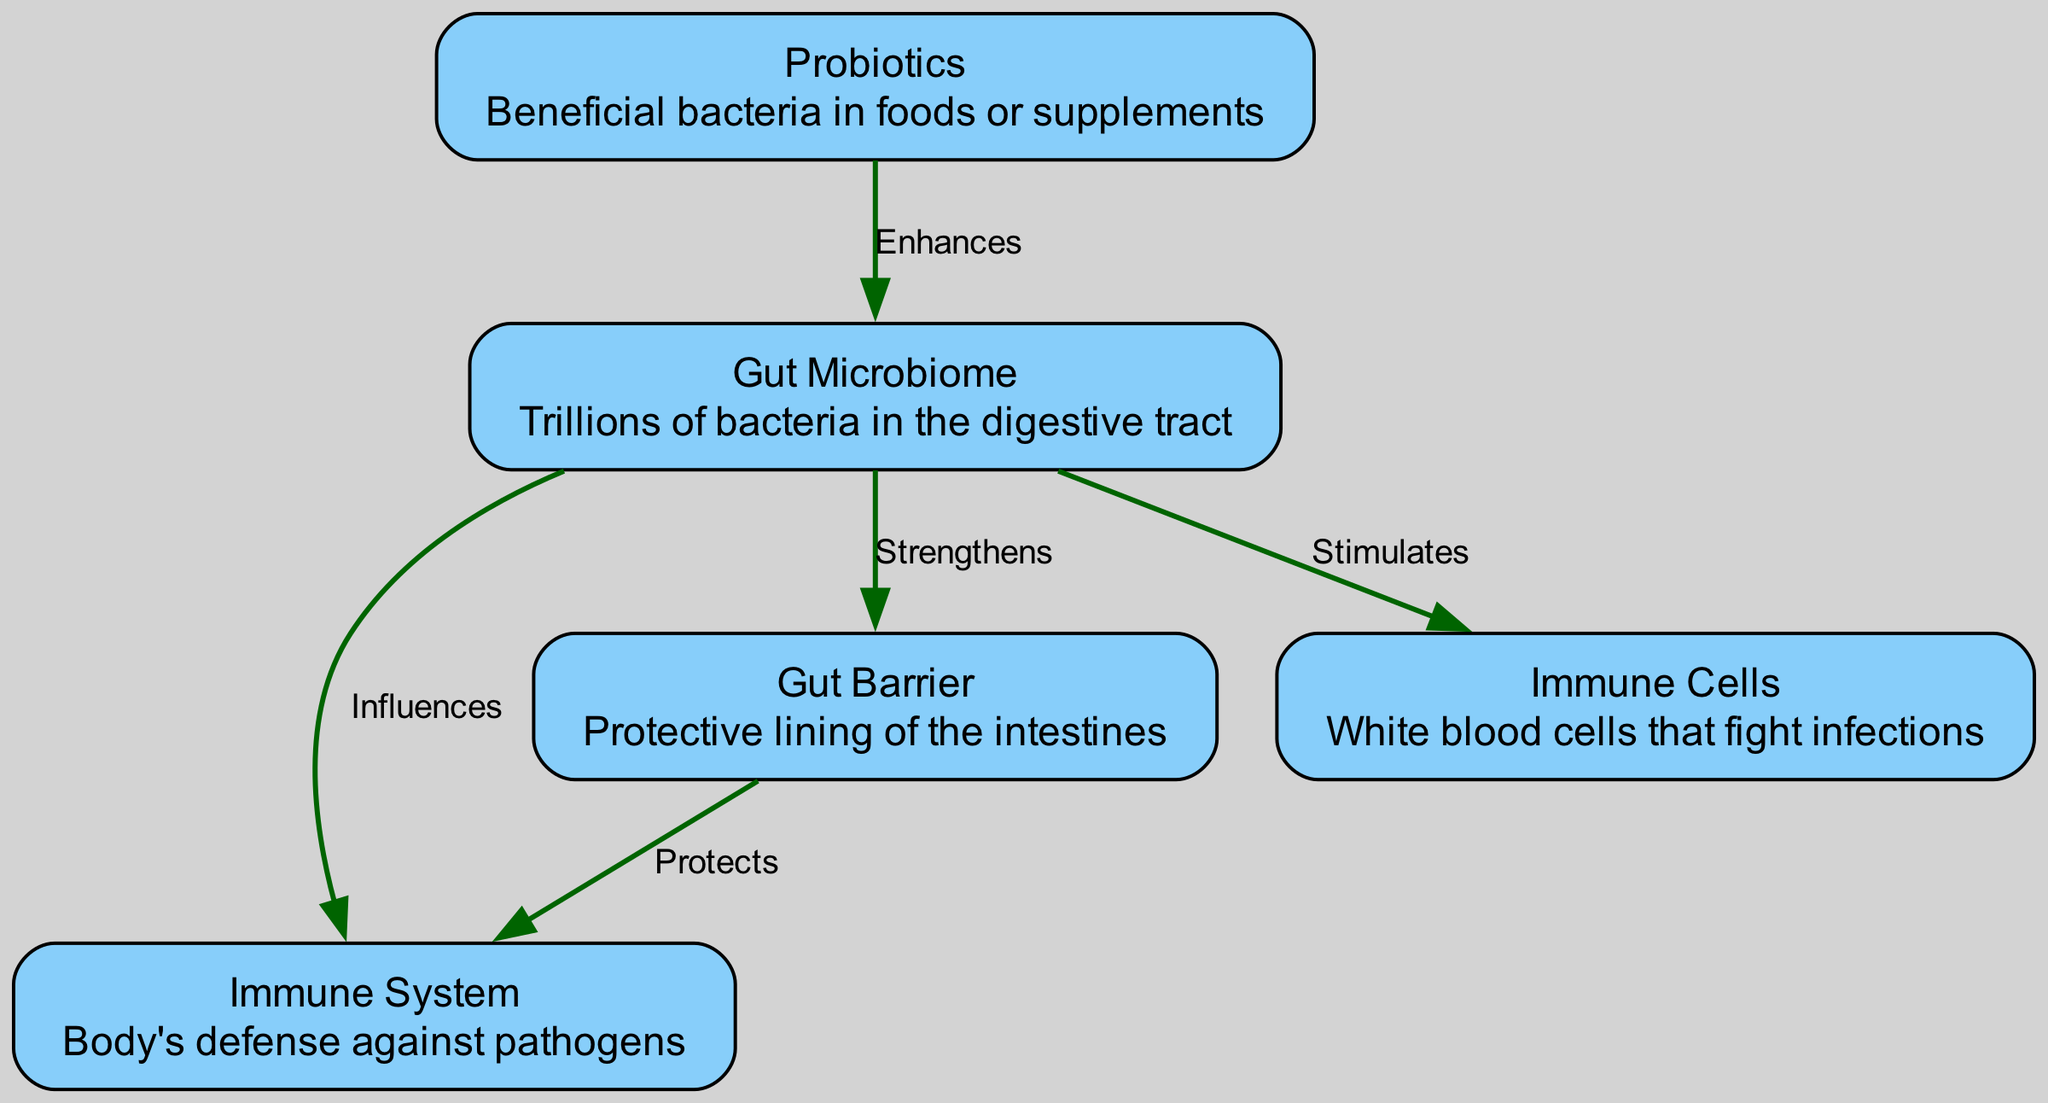How many nodes are in the diagram? The diagram contains five distinct entities, referred to as nodes: Gut Microbiome, Immune System, Probiotics, Gut Barrier, and Immune Cells. Counting these nodes gives a total of five.
Answer: 5 What does Probiotics enhance? The diagram shows that Probiotics have a direct relationship with the Gut Microbiome, specifically enhancing it. This suggests that Probiotics contribute to the health or functionality of the Gut Microbiome.
Answer: Gut Microbiome What is the role of the Gut Barrier? The Gut Barrier is depicted in the diagram as strengthening the Gut Microbiome and protecting the Immune System, which highlights its dual role in both fortifying the microbiome and acting as a defense for the immune system.
Answer: Strengthens and Protects Which node stimulates Immune Cells? According to the diagram, the Gut Microbiome directly stimulates Immune Cells. This relationship indicates that the health of the Gut Microbiome plays a significant role in the activation or functionality of the immune system's cells.
Answer: Gut Microbiome How does Gut Microbiome influence the Immune System? The diagram illustrates a direct line between the Gut Microbiome and the Immune System, labeled as "Influences." This implies that changes or conditions in the Gut Microbiome have a bearing on how effectively the Immune System operates.
Answer: Influences Explain the flow from Probiotics to Immune Cells. The flow starts with Probiotics enhancing the Gut Microbiome. A healthy Gut Microbiome then stimulates Immune Cells, indicating that the presence of beneficial bacteria is crucial for supporting immune function. Thus, a pathway exists from Probiotics to Immune Cells through the Gut Microbiome.
Answer: Probiotics → Gut Microbiome → Immune Cells What does the Gut Barrier protect? The diagram specifies that the Gut Barrier protects the Immune System, suggesting a layer of defense that helps to prevent pathogens or harmful substances from compromising immune function.
Answer: Immune System What is the relationship between Gut Microbiome and Gut Barrier? The relationship between these two nodes is described in the diagram as “Strengthens,” indicating that a healthy Gut Microbiome plays a vital role in reinforcing the integrity of the Gut Barrier, which is crucial for maintaining overall gut health.
Answer: Strengthens Which entities are connected by the label "Protects"? The label "Protects" connects the Gut Barrier and the Immune System, illustrating that the protective role of the Gut Barrier extends to safeguarding the Immune System from external threats that could disrupt immune functions.
Answer: Gut Barrier and Immune System 